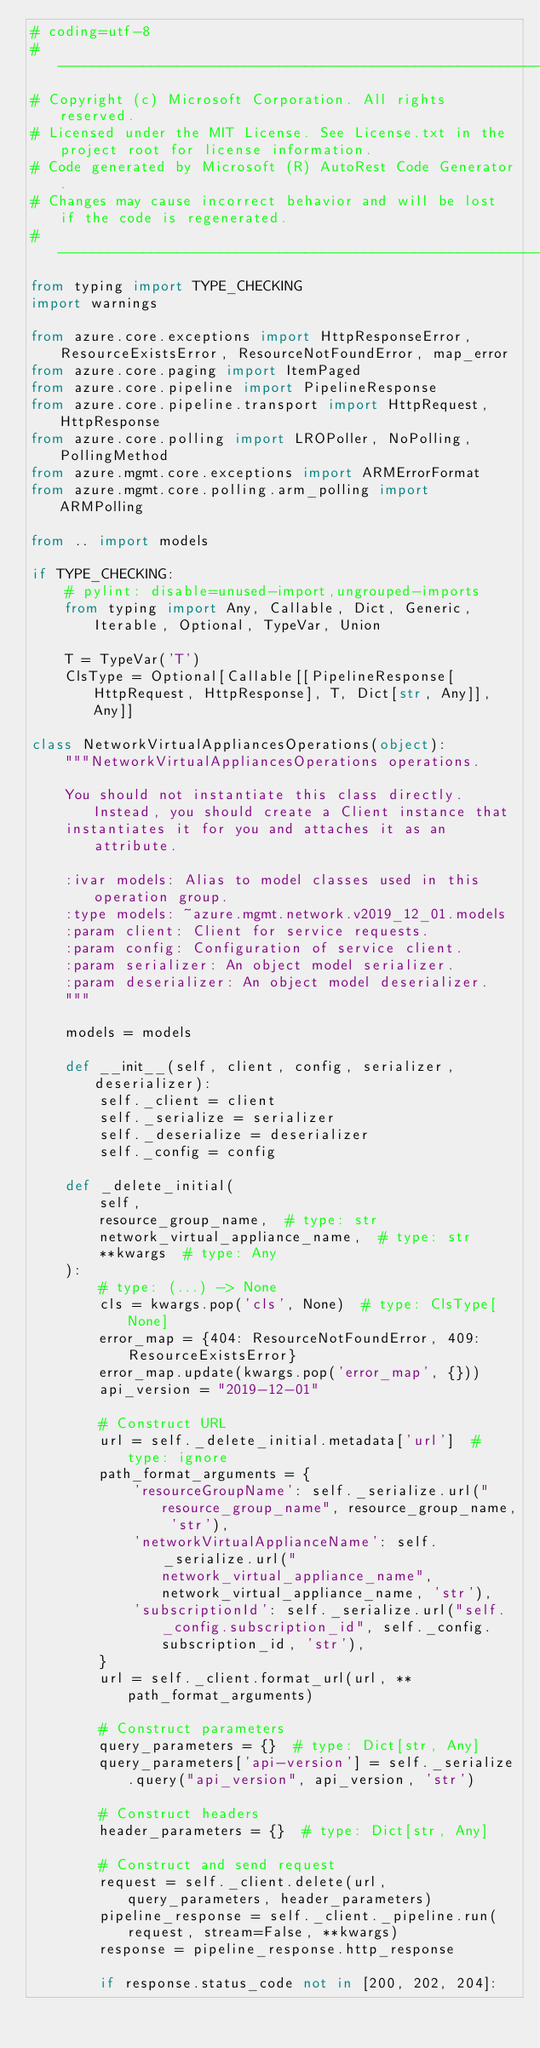<code> <loc_0><loc_0><loc_500><loc_500><_Python_># coding=utf-8
# --------------------------------------------------------------------------
# Copyright (c) Microsoft Corporation. All rights reserved.
# Licensed under the MIT License. See License.txt in the project root for license information.
# Code generated by Microsoft (R) AutoRest Code Generator.
# Changes may cause incorrect behavior and will be lost if the code is regenerated.
# --------------------------------------------------------------------------
from typing import TYPE_CHECKING
import warnings

from azure.core.exceptions import HttpResponseError, ResourceExistsError, ResourceNotFoundError, map_error
from azure.core.paging import ItemPaged
from azure.core.pipeline import PipelineResponse
from azure.core.pipeline.transport import HttpRequest, HttpResponse
from azure.core.polling import LROPoller, NoPolling, PollingMethod
from azure.mgmt.core.exceptions import ARMErrorFormat
from azure.mgmt.core.polling.arm_polling import ARMPolling

from .. import models

if TYPE_CHECKING:
    # pylint: disable=unused-import,ungrouped-imports
    from typing import Any, Callable, Dict, Generic, Iterable, Optional, TypeVar, Union

    T = TypeVar('T')
    ClsType = Optional[Callable[[PipelineResponse[HttpRequest, HttpResponse], T, Dict[str, Any]], Any]]

class NetworkVirtualAppliancesOperations(object):
    """NetworkVirtualAppliancesOperations operations.

    You should not instantiate this class directly. Instead, you should create a Client instance that
    instantiates it for you and attaches it as an attribute.

    :ivar models: Alias to model classes used in this operation group.
    :type models: ~azure.mgmt.network.v2019_12_01.models
    :param client: Client for service requests.
    :param config: Configuration of service client.
    :param serializer: An object model serializer.
    :param deserializer: An object model deserializer.
    """

    models = models

    def __init__(self, client, config, serializer, deserializer):
        self._client = client
        self._serialize = serializer
        self._deserialize = deserializer
        self._config = config

    def _delete_initial(
        self,
        resource_group_name,  # type: str
        network_virtual_appliance_name,  # type: str
        **kwargs  # type: Any
    ):
        # type: (...) -> None
        cls = kwargs.pop('cls', None)  # type: ClsType[None]
        error_map = {404: ResourceNotFoundError, 409: ResourceExistsError}
        error_map.update(kwargs.pop('error_map', {}))
        api_version = "2019-12-01"

        # Construct URL
        url = self._delete_initial.metadata['url']  # type: ignore
        path_format_arguments = {
            'resourceGroupName': self._serialize.url("resource_group_name", resource_group_name, 'str'),
            'networkVirtualApplianceName': self._serialize.url("network_virtual_appliance_name", network_virtual_appliance_name, 'str'),
            'subscriptionId': self._serialize.url("self._config.subscription_id", self._config.subscription_id, 'str'),
        }
        url = self._client.format_url(url, **path_format_arguments)

        # Construct parameters
        query_parameters = {}  # type: Dict[str, Any]
        query_parameters['api-version'] = self._serialize.query("api_version", api_version, 'str')

        # Construct headers
        header_parameters = {}  # type: Dict[str, Any]

        # Construct and send request
        request = self._client.delete(url, query_parameters, header_parameters)
        pipeline_response = self._client._pipeline.run(request, stream=False, **kwargs)
        response = pipeline_response.http_response

        if response.status_code not in [200, 202, 204]:</code> 